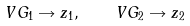Convert formula to latex. <formula><loc_0><loc_0><loc_500><loc_500>V G _ { 1 } \rightarrow z _ { 1 } , \quad V G _ { 2 } \rightarrow z _ { 2 }</formula> 